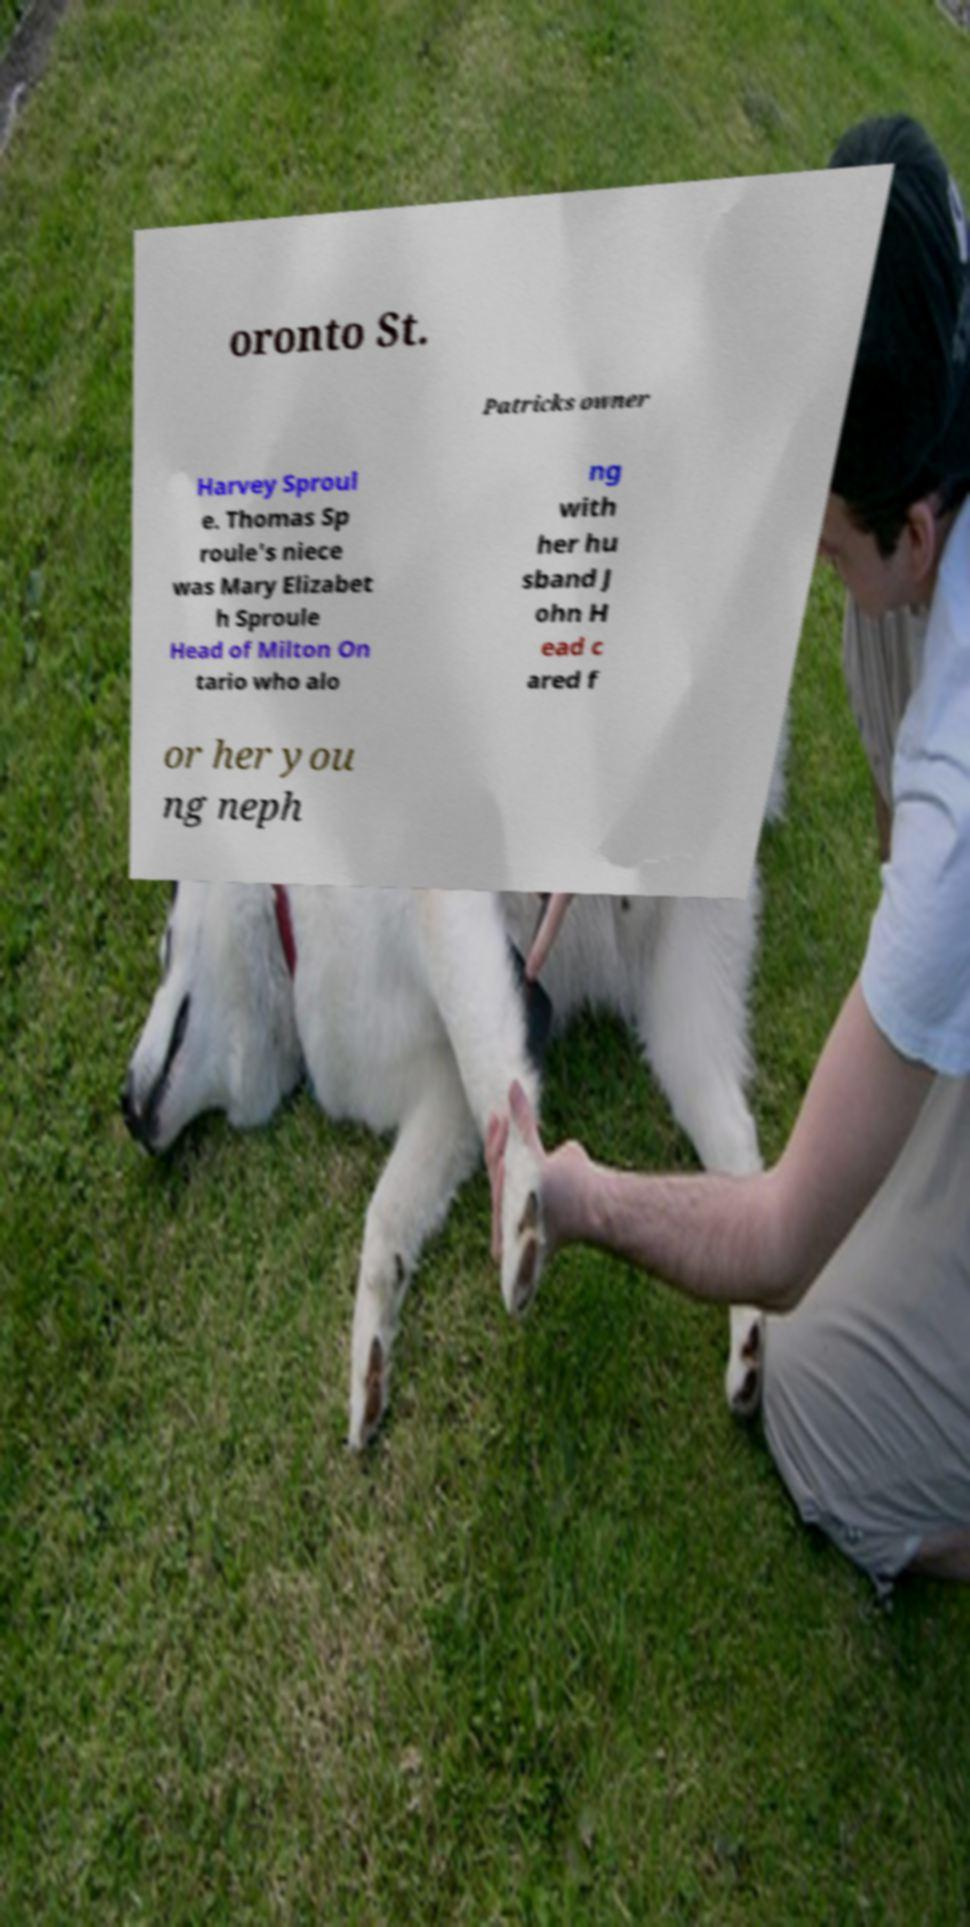There's text embedded in this image that I need extracted. Can you transcribe it verbatim? oronto St. Patricks owner Harvey Sproul e. Thomas Sp roule's niece was Mary Elizabet h Sproule Head of Milton On tario who alo ng with her hu sband J ohn H ead c ared f or her you ng neph 